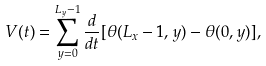<formula> <loc_0><loc_0><loc_500><loc_500>V ( t ) = \sum _ { y = 0 } ^ { L _ { y } - 1 } \frac { d } { d t } [ \theta ( L _ { x } - 1 , y ) - \theta ( 0 , y ) ] ,</formula> 